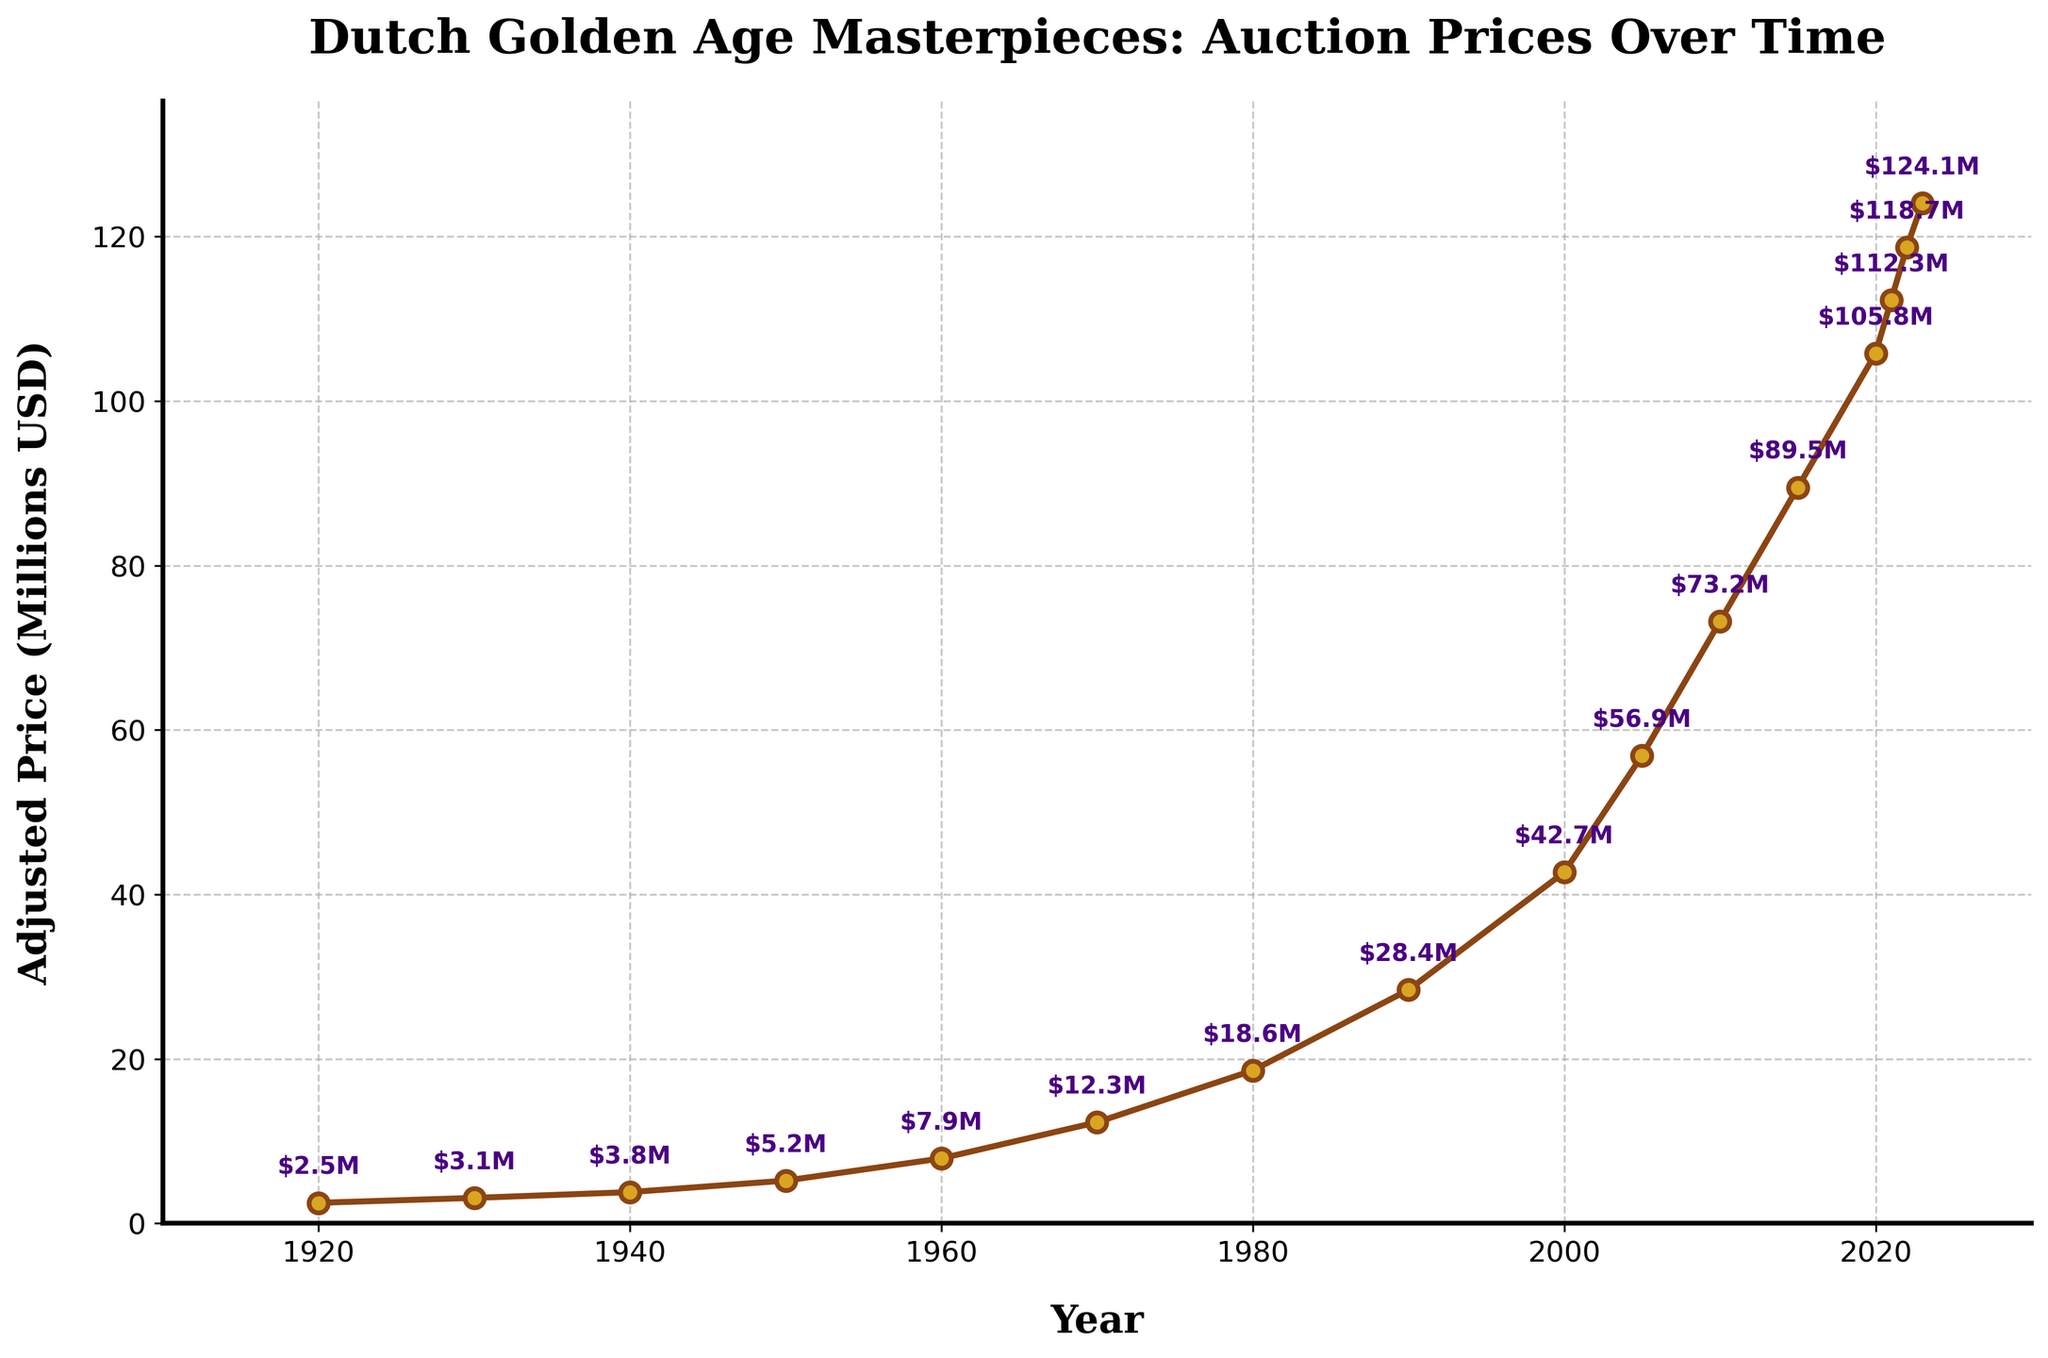What's the general trend in auction prices of Dutch Golden Age masterpieces from 1920 to 2023? The auction prices show a steady increase. Prices started at $2.5 million in 1920 and reached $124.1 million in 2023. This indicates a significant growth over the century.
Answer: Increasing Which year saw the highest increase in auction prices compared to the previous year? To determine this, observe the differences in prices year over year. The largest increase occurred between 2000 ($42.7M) and 2005 ($56.9M), which is $14.2 million.
Answer: 2005 How much did the auction price increase from 2010 to 2020? The price in 2010 was $73.2 million and it increased to $105.8 million in 2020. The difference is $105.8M - $73.2M = $32.6 million.
Answer: $32.6 million What is the average auction price in the first half of the century (1920-1970)? Add the prices from 1920 ($2.5M), 1930 ($3.1M), 1940 ($3.8M), 1950 ($5.2M), and 1960 ($7.9M), and 1970 ($12.3M). The total sum is $34.8M. There are 6 data points, so the average is $34.8M / 6 ≈ $5.8M.
Answer: $5.8 million How do the prices in 2023 compare to the prices in 1980? The price in 1980 was $18.6 million, and in 2023 it is $124.1 million. 2023's price is significantly higher, specifically $124.1M - $18.6M = $105.5 million more.
Answer: $105.5 million higher Between which two consecutive years did the prices increase by about $6.4 million? Check the difference year-by-year until finding the closest match to $6.4 million. Between 2021 ($112.3M) and 2022 ($118.7M), the increase is $118.7M - $112.3M = $6.4 million.
Answer: 2021 and 2022 What proportion of the total increase in value since 1920 has occurred since 2000? The price in 1920 was $2.5M and in 2000 was $42.7M, a $40.2M increase. From 2000 to 2023, the increase is $124.1M - $42.7M = $81.4M. The total increase from 1920 to 2023 is $124.1M - $2.5M = $121.6M, so the proportion since 2000 is $81.4M / $121.6M ≈ 67%.
Answer: 67% What is the median auction price over the entire dataset? There are 16 data points. Arrange the prices in ascending order, choose the middle two values and calculate their average. The middle values are $12.3M and $18.6M, thus median is ($12.3M + $18.6M) / 2 = $15.45 million.
Answer: $15.45 million 